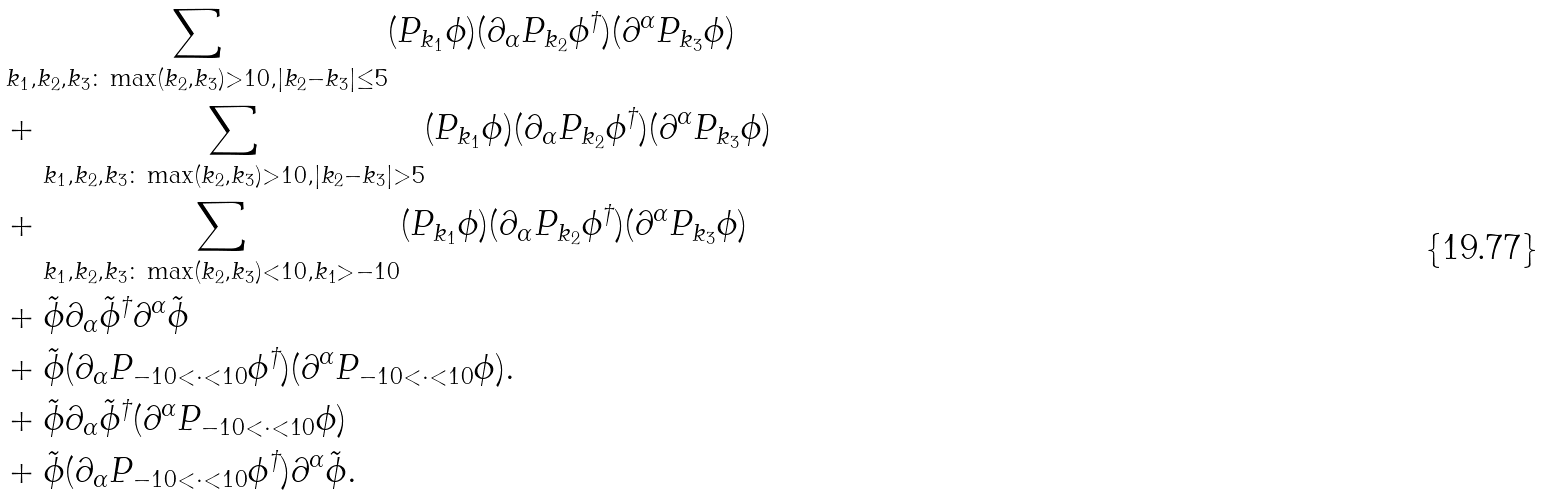<formula> <loc_0><loc_0><loc_500><loc_500>& \sum _ { k _ { 1 } , k _ { 2 } , k _ { 3 } \colon \max ( k _ { 2 } , k _ { 3 } ) > 1 0 , | k _ { 2 } - k _ { 3 } | \leq 5 } ( P _ { k _ { 1 } } \phi ) ( \partial _ { \alpha } P _ { k _ { 2 } } \phi ^ { \dagger } ) ( \partial ^ { \alpha } P _ { k _ { 3 } } \phi ) \\ & + \sum _ { k _ { 1 } , k _ { 2 } , k _ { 3 } \colon \max ( k _ { 2 } , k _ { 3 } ) > 1 0 , | k _ { 2 } - k _ { 3 } | > 5 } ( P _ { k _ { 1 } } \phi ) ( \partial _ { \alpha } P _ { k _ { 2 } } \phi ^ { \dagger } ) ( \partial ^ { \alpha } P _ { k _ { 3 } } \phi ) \\ & + \sum _ { k _ { 1 } , k _ { 2 } , k _ { 3 } \colon \max ( k _ { 2 } , k _ { 3 } ) < 1 0 , k _ { 1 } > - 1 0 } ( P _ { k _ { 1 } } \phi ) ( \partial _ { \alpha } P _ { k _ { 2 } } \phi ^ { \dagger } ) ( \partial ^ { \alpha } P _ { k _ { 3 } } \phi ) \\ & + \tilde { \phi } \partial _ { \alpha } \tilde { \phi } ^ { \dagger } \partial ^ { \alpha } \tilde { \phi } \\ & + \tilde { \phi } ( \partial _ { \alpha } P _ { - 1 0 < \cdot < 1 0 } \phi ^ { \dagger } ) ( \partial ^ { \alpha } P _ { - 1 0 < \cdot < 1 0 } \phi ) . \\ & + \tilde { \phi } \partial _ { \alpha } \tilde { \phi } ^ { \dagger } ( \partial ^ { \alpha } P _ { - 1 0 < \cdot < 1 0 } \phi ) \\ & + \tilde { \phi } ( \partial _ { \alpha } P _ { - 1 0 < \cdot < 1 0 } \phi ^ { \dagger } ) \partial ^ { \alpha } \tilde { \phi } .</formula> 